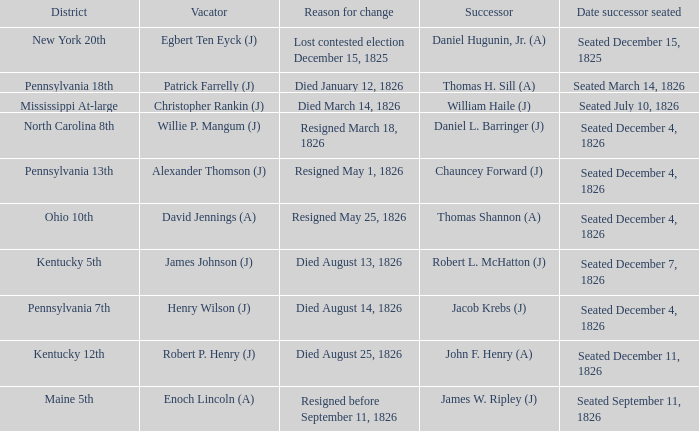Name the vacator for reason for change died january 12, 1826 Patrick Farrelly (J). 